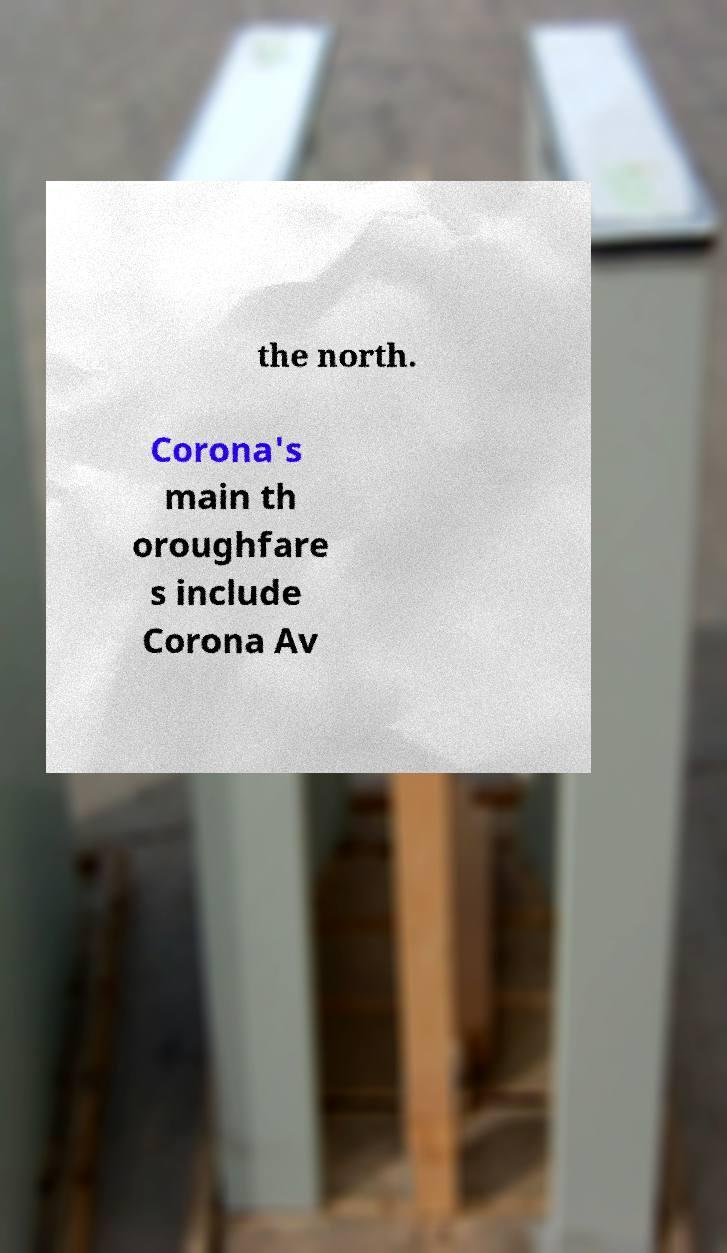For documentation purposes, I need the text within this image transcribed. Could you provide that? the north. Corona's main th oroughfare s include Corona Av 